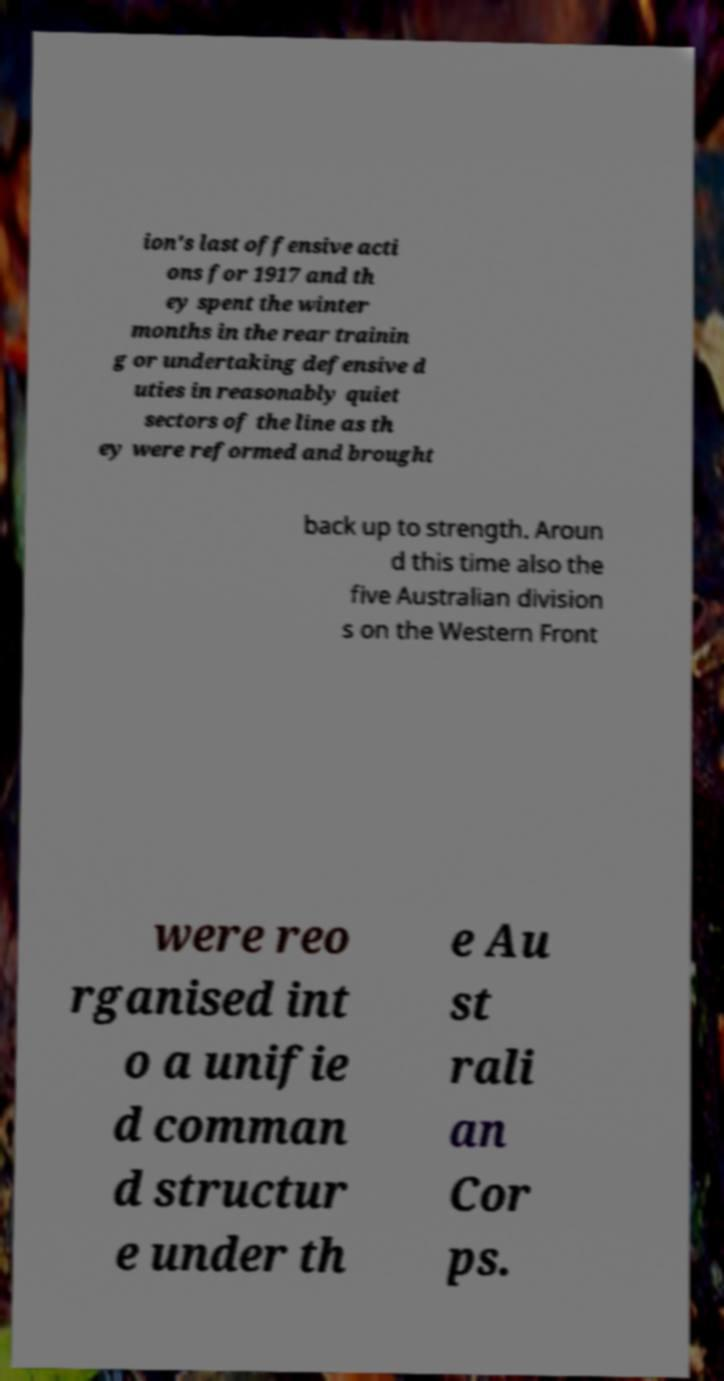Could you extract and type out the text from this image? ion's last offensive acti ons for 1917 and th ey spent the winter months in the rear trainin g or undertaking defensive d uties in reasonably quiet sectors of the line as th ey were reformed and brought back up to strength. Aroun d this time also the five Australian division s on the Western Front were reo rganised int o a unifie d comman d structur e under th e Au st rali an Cor ps. 